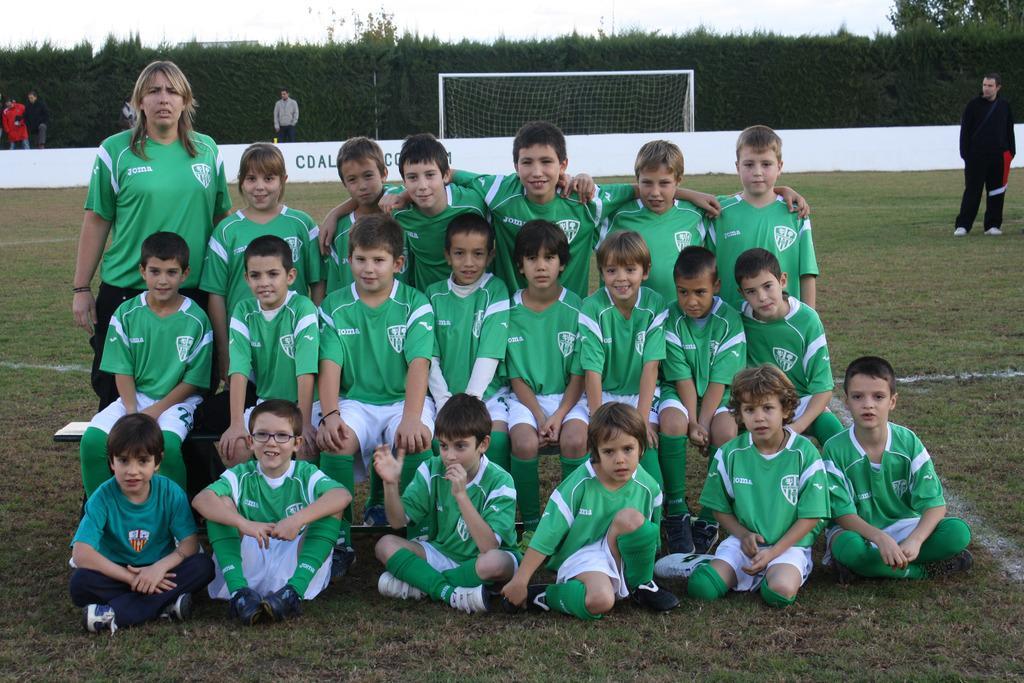Describe this image in one or two sentences. In this image there are group of kids who are wearing the green colour jersey are posing for the picture. In the background there is a goal post. On the left side there is a woman. Behind the goal post there are trees and boundary. On the right side there is a person standing on the ground. At the top there is the sky. 